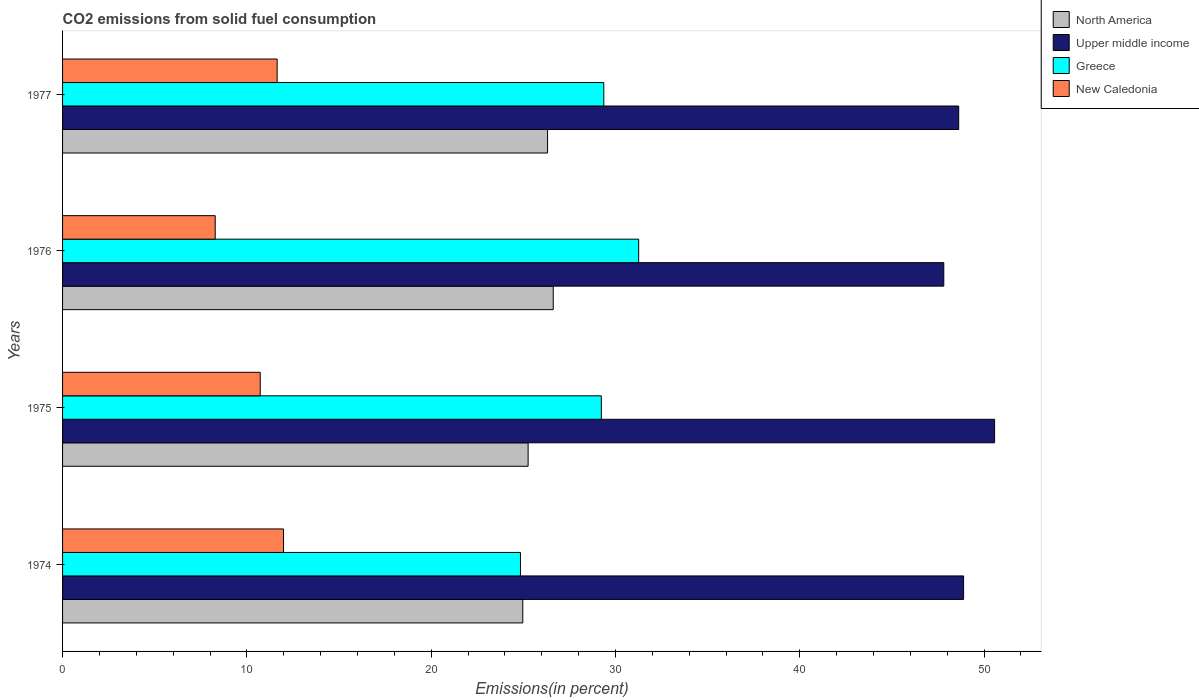How many different coloured bars are there?
Ensure brevity in your answer.  4. How many bars are there on the 4th tick from the top?
Your answer should be compact. 4. What is the label of the 4th group of bars from the top?
Offer a very short reply. 1974. In how many cases, is the number of bars for a given year not equal to the number of legend labels?
Give a very brief answer. 0. What is the total CO2 emitted in North America in 1974?
Your response must be concise. 24.97. Across all years, what is the maximum total CO2 emitted in North America?
Your answer should be very brief. 26.62. Across all years, what is the minimum total CO2 emitted in North America?
Keep it short and to the point. 24.97. In which year was the total CO2 emitted in New Caledonia maximum?
Give a very brief answer. 1974. In which year was the total CO2 emitted in New Caledonia minimum?
Your answer should be compact. 1976. What is the total total CO2 emitted in New Caledonia in the graph?
Give a very brief answer. 42.64. What is the difference between the total CO2 emitted in North America in 1976 and that in 1977?
Offer a very short reply. 0.31. What is the difference between the total CO2 emitted in North America in 1976 and the total CO2 emitted in Greece in 1974?
Offer a terse response. 1.78. What is the average total CO2 emitted in North America per year?
Offer a very short reply. 25.79. In the year 1976, what is the difference between the total CO2 emitted in New Caledonia and total CO2 emitted in North America?
Your answer should be very brief. -18.34. What is the ratio of the total CO2 emitted in North America in 1975 to that in 1977?
Make the answer very short. 0.96. Is the difference between the total CO2 emitted in New Caledonia in 1976 and 1977 greater than the difference between the total CO2 emitted in North America in 1976 and 1977?
Your answer should be very brief. No. What is the difference between the highest and the second highest total CO2 emitted in Greece?
Your response must be concise. 1.89. What is the difference between the highest and the lowest total CO2 emitted in Greece?
Offer a terse response. 6.41. In how many years, is the total CO2 emitted in Greece greater than the average total CO2 emitted in Greece taken over all years?
Your answer should be very brief. 3. Is it the case that in every year, the sum of the total CO2 emitted in Upper middle income and total CO2 emitted in North America is greater than the sum of total CO2 emitted in New Caledonia and total CO2 emitted in Greece?
Your answer should be very brief. Yes. What does the 3rd bar from the top in 1977 represents?
Provide a succinct answer. Upper middle income. What does the 3rd bar from the bottom in 1977 represents?
Provide a short and direct response. Greece. Is it the case that in every year, the sum of the total CO2 emitted in New Caledonia and total CO2 emitted in Greece is greater than the total CO2 emitted in Upper middle income?
Keep it short and to the point. No. How many years are there in the graph?
Keep it short and to the point. 4. Are the values on the major ticks of X-axis written in scientific E-notation?
Your answer should be very brief. No. How are the legend labels stacked?
Keep it short and to the point. Vertical. What is the title of the graph?
Provide a succinct answer. CO2 emissions from solid fuel consumption. Does "Indonesia" appear as one of the legend labels in the graph?
Provide a succinct answer. No. What is the label or title of the X-axis?
Make the answer very short. Emissions(in percent). What is the label or title of the Y-axis?
Your answer should be very brief. Years. What is the Emissions(in percent) in North America in 1974?
Your answer should be compact. 24.97. What is the Emissions(in percent) in Upper middle income in 1974?
Offer a terse response. 48.89. What is the Emissions(in percent) in Greece in 1974?
Your answer should be very brief. 24.85. What is the Emissions(in percent) of New Caledonia in 1974?
Give a very brief answer. 11.99. What is the Emissions(in percent) of North America in 1975?
Ensure brevity in your answer.  25.26. What is the Emissions(in percent) of Upper middle income in 1975?
Provide a succinct answer. 50.57. What is the Emissions(in percent) in Greece in 1975?
Ensure brevity in your answer.  29.23. What is the Emissions(in percent) in New Caledonia in 1975?
Your answer should be very brief. 10.72. What is the Emissions(in percent) of North America in 1976?
Keep it short and to the point. 26.62. What is the Emissions(in percent) in Upper middle income in 1976?
Give a very brief answer. 47.81. What is the Emissions(in percent) of Greece in 1976?
Ensure brevity in your answer.  31.26. What is the Emissions(in percent) of New Caledonia in 1976?
Your response must be concise. 8.28. What is the Emissions(in percent) in North America in 1977?
Provide a succinct answer. 26.32. What is the Emissions(in percent) of Upper middle income in 1977?
Your answer should be compact. 48.62. What is the Emissions(in percent) of Greece in 1977?
Your response must be concise. 29.37. What is the Emissions(in percent) of New Caledonia in 1977?
Ensure brevity in your answer.  11.64. Across all years, what is the maximum Emissions(in percent) of North America?
Your answer should be very brief. 26.62. Across all years, what is the maximum Emissions(in percent) in Upper middle income?
Provide a succinct answer. 50.57. Across all years, what is the maximum Emissions(in percent) in Greece?
Offer a terse response. 31.26. Across all years, what is the maximum Emissions(in percent) in New Caledonia?
Give a very brief answer. 11.99. Across all years, what is the minimum Emissions(in percent) in North America?
Keep it short and to the point. 24.97. Across all years, what is the minimum Emissions(in percent) of Upper middle income?
Offer a terse response. 47.81. Across all years, what is the minimum Emissions(in percent) of Greece?
Provide a short and direct response. 24.85. Across all years, what is the minimum Emissions(in percent) of New Caledonia?
Your answer should be compact. 8.28. What is the total Emissions(in percent) of North America in the graph?
Ensure brevity in your answer.  103.17. What is the total Emissions(in percent) of Upper middle income in the graph?
Your response must be concise. 195.9. What is the total Emissions(in percent) in Greece in the graph?
Your response must be concise. 114.71. What is the total Emissions(in percent) in New Caledonia in the graph?
Your answer should be very brief. 42.64. What is the difference between the Emissions(in percent) in North America in 1974 and that in 1975?
Ensure brevity in your answer.  -0.29. What is the difference between the Emissions(in percent) in Upper middle income in 1974 and that in 1975?
Give a very brief answer. -1.68. What is the difference between the Emissions(in percent) in Greece in 1974 and that in 1975?
Provide a succinct answer. -4.39. What is the difference between the Emissions(in percent) in New Caledonia in 1974 and that in 1975?
Offer a very short reply. 1.26. What is the difference between the Emissions(in percent) of North America in 1974 and that in 1976?
Your response must be concise. -1.65. What is the difference between the Emissions(in percent) in Upper middle income in 1974 and that in 1976?
Give a very brief answer. 1.08. What is the difference between the Emissions(in percent) of Greece in 1974 and that in 1976?
Offer a very short reply. -6.41. What is the difference between the Emissions(in percent) of New Caledonia in 1974 and that in 1976?
Your answer should be very brief. 3.71. What is the difference between the Emissions(in percent) in North America in 1974 and that in 1977?
Provide a short and direct response. -1.34. What is the difference between the Emissions(in percent) in Upper middle income in 1974 and that in 1977?
Your response must be concise. 0.27. What is the difference between the Emissions(in percent) of Greece in 1974 and that in 1977?
Ensure brevity in your answer.  -4.52. What is the difference between the Emissions(in percent) in New Caledonia in 1974 and that in 1977?
Your answer should be compact. 0.35. What is the difference between the Emissions(in percent) of North America in 1975 and that in 1976?
Your answer should be compact. -1.36. What is the difference between the Emissions(in percent) of Upper middle income in 1975 and that in 1976?
Make the answer very short. 2.76. What is the difference between the Emissions(in percent) in Greece in 1975 and that in 1976?
Your response must be concise. -2.03. What is the difference between the Emissions(in percent) in New Caledonia in 1975 and that in 1976?
Provide a short and direct response. 2.44. What is the difference between the Emissions(in percent) of North America in 1975 and that in 1977?
Provide a short and direct response. -1.05. What is the difference between the Emissions(in percent) in Upper middle income in 1975 and that in 1977?
Ensure brevity in your answer.  1.95. What is the difference between the Emissions(in percent) of Greece in 1975 and that in 1977?
Offer a terse response. -0.13. What is the difference between the Emissions(in percent) in New Caledonia in 1975 and that in 1977?
Keep it short and to the point. -0.92. What is the difference between the Emissions(in percent) of North America in 1976 and that in 1977?
Keep it short and to the point. 0.31. What is the difference between the Emissions(in percent) in Upper middle income in 1976 and that in 1977?
Offer a very short reply. -0.81. What is the difference between the Emissions(in percent) in Greece in 1976 and that in 1977?
Make the answer very short. 1.89. What is the difference between the Emissions(in percent) of New Caledonia in 1976 and that in 1977?
Your response must be concise. -3.36. What is the difference between the Emissions(in percent) in North America in 1974 and the Emissions(in percent) in Upper middle income in 1975?
Keep it short and to the point. -25.6. What is the difference between the Emissions(in percent) of North America in 1974 and the Emissions(in percent) of Greece in 1975?
Give a very brief answer. -4.26. What is the difference between the Emissions(in percent) of North America in 1974 and the Emissions(in percent) of New Caledonia in 1975?
Offer a terse response. 14.25. What is the difference between the Emissions(in percent) in Upper middle income in 1974 and the Emissions(in percent) in Greece in 1975?
Your response must be concise. 19.66. What is the difference between the Emissions(in percent) in Upper middle income in 1974 and the Emissions(in percent) in New Caledonia in 1975?
Offer a very short reply. 38.17. What is the difference between the Emissions(in percent) in Greece in 1974 and the Emissions(in percent) in New Caledonia in 1975?
Provide a short and direct response. 14.12. What is the difference between the Emissions(in percent) of North America in 1974 and the Emissions(in percent) of Upper middle income in 1976?
Ensure brevity in your answer.  -22.84. What is the difference between the Emissions(in percent) in North America in 1974 and the Emissions(in percent) in Greece in 1976?
Your response must be concise. -6.29. What is the difference between the Emissions(in percent) of North America in 1974 and the Emissions(in percent) of New Caledonia in 1976?
Keep it short and to the point. 16.69. What is the difference between the Emissions(in percent) in Upper middle income in 1974 and the Emissions(in percent) in Greece in 1976?
Your answer should be compact. 17.63. What is the difference between the Emissions(in percent) of Upper middle income in 1974 and the Emissions(in percent) of New Caledonia in 1976?
Ensure brevity in your answer.  40.61. What is the difference between the Emissions(in percent) of Greece in 1974 and the Emissions(in percent) of New Caledonia in 1976?
Keep it short and to the point. 16.56. What is the difference between the Emissions(in percent) of North America in 1974 and the Emissions(in percent) of Upper middle income in 1977?
Your response must be concise. -23.65. What is the difference between the Emissions(in percent) of North America in 1974 and the Emissions(in percent) of Greece in 1977?
Ensure brevity in your answer.  -4.4. What is the difference between the Emissions(in percent) of North America in 1974 and the Emissions(in percent) of New Caledonia in 1977?
Give a very brief answer. 13.33. What is the difference between the Emissions(in percent) in Upper middle income in 1974 and the Emissions(in percent) in Greece in 1977?
Your answer should be compact. 19.52. What is the difference between the Emissions(in percent) of Upper middle income in 1974 and the Emissions(in percent) of New Caledonia in 1977?
Make the answer very short. 37.25. What is the difference between the Emissions(in percent) in Greece in 1974 and the Emissions(in percent) in New Caledonia in 1977?
Ensure brevity in your answer.  13.2. What is the difference between the Emissions(in percent) in North America in 1975 and the Emissions(in percent) in Upper middle income in 1976?
Provide a succinct answer. -22.55. What is the difference between the Emissions(in percent) of North America in 1975 and the Emissions(in percent) of Greece in 1976?
Your answer should be very brief. -6. What is the difference between the Emissions(in percent) in North America in 1975 and the Emissions(in percent) in New Caledonia in 1976?
Your answer should be compact. 16.98. What is the difference between the Emissions(in percent) of Upper middle income in 1975 and the Emissions(in percent) of Greece in 1976?
Keep it short and to the point. 19.31. What is the difference between the Emissions(in percent) in Upper middle income in 1975 and the Emissions(in percent) in New Caledonia in 1976?
Offer a very short reply. 42.29. What is the difference between the Emissions(in percent) of Greece in 1975 and the Emissions(in percent) of New Caledonia in 1976?
Offer a terse response. 20.95. What is the difference between the Emissions(in percent) of North America in 1975 and the Emissions(in percent) of Upper middle income in 1977?
Offer a very short reply. -23.36. What is the difference between the Emissions(in percent) of North America in 1975 and the Emissions(in percent) of Greece in 1977?
Your answer should be very brief. -4.11. What is the difference between the Emissions(in percent) of North America in 1975 and the Emissions(in percent) of New Caledonia in 1977?
Offer a terse response. 13.62. What is the difference between the Emissions(in percent) of Upper middle income in 1975 and the Emissions(in percent) of Greece in 1977?
Make the answer very short. 21.21. What is the difference between the Emissions(in percent) in Upper middle income in 1975 and the Emissions(in percent) in New Caledonia in 1977?
Ensure brevity in your answer.  38.93. What is the difference between the Emissions(in percent) in Greece in 1975 and the Emissions(in percent) in New Caledonia in 1977?
Your answer should be compact. 17.59. What is the difference between the Emissions(in percent) in North America in 1976 and the Emissions(in percent) in Upper middle income in 1977?
Your response must be concise. -22. What is the difference between the Emissions(in percent) in North America in 1976 and the Emissions(in percent) in Greece in 1977?
Provide a short and direct response. -2.74. What is the difference between the Emissions(in percent) of North America in 1976 and the Emissions(in percent) of New Caledonia in 1977?
Provide a succinct answer. 14.98. What is the difference between the Emissions(in percent) of Upper middle income in 1976 and the Emissions(in percent) of Greece in 1977?
Offer a very short reply. 18.45. What is the difference between the Emissions(in percent) in Upper middle income in 1976 and the Emissions(in percent) in New Caledonia in 1977?
Give a very brief answer. 36.17. What is the difference between the Emissions(in percent) in Greece in 1976 and the Emissions(in percent) in New Caledonia in 1977?
Ensure brevity in your answer.  19.62. What is the average Emissions(in percent) of North America per year?
Your answer should be very brief. 25.79. What is the average Emissions(in percent) in Upper middle income per year?
Give a very brief answer. 48.98. What is the average Emissions(in percent) of Greece per year?
Provide a succinct answer. 28.68. What is the average Emissions(in percent) of New Caledonia per year?
Your answer should be very brief. 10.66. In the year 1974, what is the difference between the Emissions(in percent) in North America and Emissions(in percent) in Upper middle income?
Provide a short and direct response. -23.92. In the year 1974, what is the difference between the Emissions(in percent) in North America and Emissions(in percent) in Greece?
Your response must be concise. 0.13. In the year 1974, what is the difference between the Emissions(in percent) in North America and Emissions(in percent) in New Caledonia?
Keep it short and to the point. 12.98. In the year 1974, what is the difference between the Emissions(in percent) of Upper middle income and Emissions(in percent) of Greece?
Keep it short and to the point. 24.04. In the year 1974, what is the difference between the Emissions(in percent) in Upper middle income and Emissions(in percent) in New Caledonia?
Your response must be concise. 36.9. In the year 1974, what is the difference between the Emissions(in percent) in Greece and Emissions(in percent) in New Caledonia?
Provide a short and direct response. 12.86. In the year 1975, what is the difference between the Emissions(in percent) in North America and Emissions(in percent) in Upper middle income?
Keep it short and to the point. -25.31. In the year 1975, what is the difference between the Emissions(in percent) of North America and Emissions(in percent) of Greece?
Your answer should be very brief. -3.97. In the year 1975, what is the difference between the Emissions(in percent) in North America and Emissions(in percent) in New Caledonia?
Your answer should be compact. 14.54. In the year 1975, what is the difference between the Emissions(in percent) in Upper middle income and Emissions(in percent) in Greece?
Give a very brief answer. 21.34. In the year 1975, what is the difference between the Emissions(in percent) of Upper middle income and Emissions(in percent) of New Caledonia?
Your response must be concise. 39.85. In the year 1975, what is the difference between the Emissions(in percent) of Greece and Emissions(in percent) of New Caledonia?
Give a very brief answer. 18.51. In the year 1976, what is the difference between the Emissions(in percent) of North America and Emissions(in percent) of Upper middle income?
Your response must be concise. -21.19. In the year 1976, what is the difference between the Emissions(in percent) of North America and Emissions(in percent) of Greece?
Ensure brevity in your answer.  -4.64. In the year 1976, what is the difference between the Emissions(in percent) of North America and Emissions(in percent) of New Caledonia?
Offer a terse response. 18.34. In the year 1976, what is the difference between the Emissions(in percent) of Upper middle income and Emissions(in percent) of Greece?
Your answer should be very brief. 16.56. In the year 1976, what is the difference between the Emissions(in percent) in Upper middle income and Emissions(in percent) in New Caledonia?
Offer a very short reply. 39.53. In the year 1976, what is the difference between the Emissions(in percent) in Greece and Emissions(in percent) in New Caledonia?
Offer a terse response. 22.98. In the year 1977, what is the difference between the Emissions(in percent) of North America and Emissions(in percent) of Upper middle income?
Make the answer very short. -22.31. In the year 1977, what is the difference between the Emissions(in percent) of North America and Emissions(in percent) of Greece?
Your answer should be very brief. -3.05. In the year 1977, what is the difference between the Emissions(in percent) in North America and Emissions(in percent) in New Caledonia?
Provide a short and direct response. 14.67. In the year 1977, what is the difference between the Emissions(in percent) in Upper middle income and Emissions(in percent) in Greece?
Provide a short and direct response. 19.26. In the year 1977, what is the difference between the Emissions(in percent) of Upper middle income and Emissions(in percent) of New Caledonia?
Offer a very short reply. 36.98. In the year 1977, what is the difference between the Emissions(in percent) in Greece and Emissions(in percent) in New Caledonia?
Provide a succinct answer. 17.72. What is the ratio of the Emissions(in percent) of Upper middle income in 1974 to that in 1975?
Your answer should be compact. 0.97. What is the ratio of the Emissions(in percent) of Greece in 1974 to that in 1975?
Offer a terse response. 0.85. What is the ratio of the Emissions(in percent) in New Caledonia in 1974 to that in 1975?
Provide a succinct answer. 1.12. What is the ratio of the Emissions(in percent) of North America in 1974 to that in 1976?
Offer a very short reply. 0.94. What is the ratio of the Emissions(in percent) of Upper middle income in 1974 to that in 1976?
Make the answer very short. 1.02. What is the ratio of the Emissions(in percent) of Greece in 1974 to that in 1976?
Your answer should be very brief. 0.79. What is the ratio of the Emissions(in percent) of New Caledonia in 1974 to that in 1976?
Ensure brevity in your answer.  1.45. What is the ratio of the Emissions(in percent) of North America in 1974 to that in 1977?
Provide a short and direct response. 0.95. What is the ratio of the Emissions(in percent) of Greece in 1974 to that in 1977?
Your answer should be very brief. 0.85. What is the ratio of the Emissions(in percent) of New Caledonia in 1974 to that in 1977?
Offer a terse response. 1.03. What is the ratio of the Emissions(in percent) in North America in 1975 to that in 1976?
Ensure brevity in your answer.  0.95. What is the ratio of the Emissions(in percent) of Upper middle income in 1975 to that in 1976?
Provide a short and direct response. 1.06. What is the ratio of the Emissions(in percent) of Greece in 1975 to that in 1976?
Offer a terse response. 0.94. What is the ratio of the Emissions(in percent) of New Caledonia in 1975 to that in 1976?
Provide a succinct answer. 1.29. What is the ratio of the Emissions(in percent) in North America in 1975 to that in 1977?
Your response must be concise. 0.96. What is the ratio of the Emissions(in percent) in Upper middle income in 1975 to that in 1977?
Your answer should be very brief. 1.04. What is the ratio of the Emissions(in percent) of Greece in 1975 to that in 1977?
Offer a very short reply. 1. What is the ratio of the Emissions(in percent) in New Caledonia in 1975 to that in 1977?
Keep it short and to the point. 0.92. What is the ratio of the Emissions(in percent) of North America in 1976 to that in 1977?
Ensure brevity in your answer.  1.01. What is the ratio of the Emissions(in percent) of Upper middle income in 1976 to that in 1977?
Provide a short and direct response. 0.98. What is the ratio of the Emissions(in percent) of Greece in 1976 to that in 1977?
Give a very brief answer. 1.06. What is the ratio of the Emissions(in percent) in New Caledonia in 1976 to that in 1977?
Your response must be concise. 0.71. What is the difference between the highest and the second highest Emissions(in percent) in North America?
Give a very brief answer. 0.31. What is the difference between the highest and the second highest Emissions(in percent) of Upper middle income?
Make the answer very short. 1.68. What is the difference between the highest and the second highest Emissions(in percent) of Greece?
Offer a very short reply. 1.89. What is the difference between the highest and the second highest Emissions(in percent) in New Caledonia?
Keep it short and to the point. 0.35. What is the difference between the highest and the lowest Emissions(in percent) in North America?
Your answer should be very brief. 1.65. What is the difference between the highest and the lowest Emissions(in percent) of Upper middle income?
Your response must be concise. 2.76. What is the difference between the highest and the lowest Emissions(in percent) in Greece?
Offer a very short reply. 6.41. What is the difference between the highest and the lowest Emissions(in percent) in New Caledonia?
Your answer should be very brief. 3.71. 